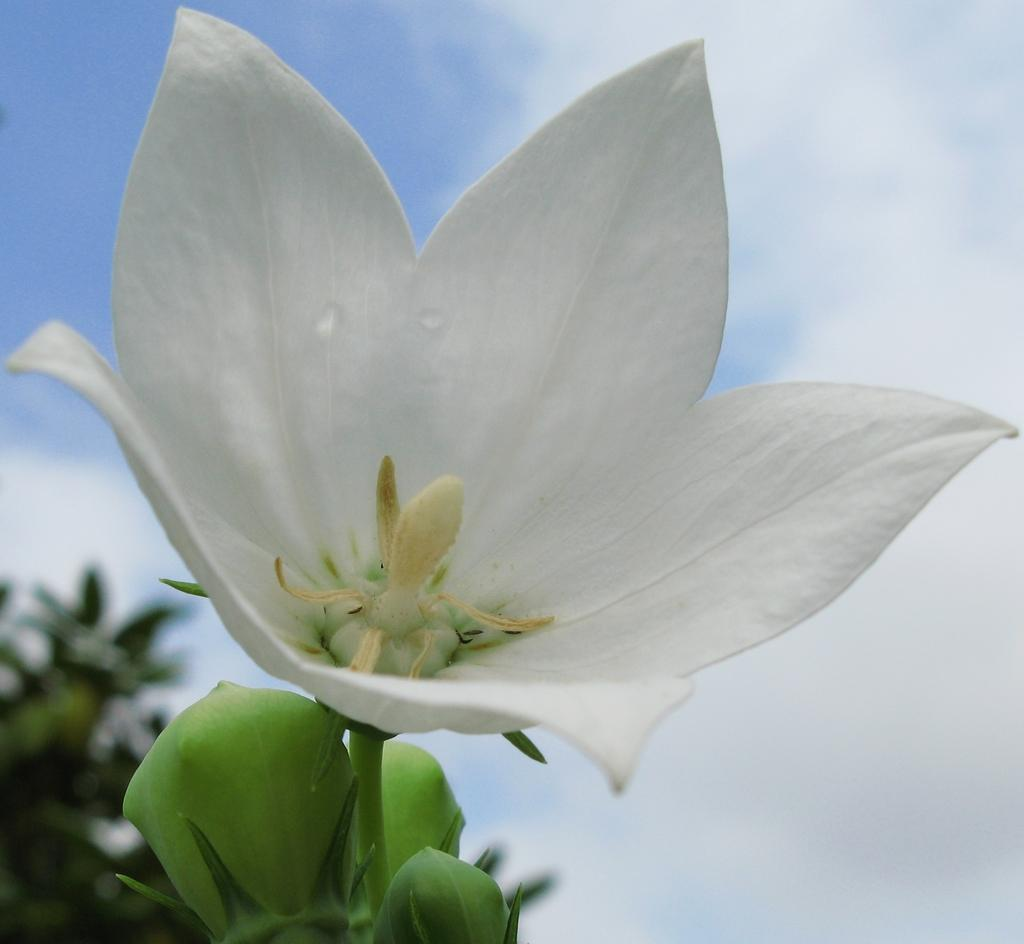What type of flower is in the image? There is a white color flower in the image. Can you describe the flower's structure? The flower has a stem and buds. What can be seen in the background of the image? There are trees and the sky visible in the background of the image. What is the condition of the sky in the image? Clouds are present in the sky. Can you tell me how many toes the tiger has in the image? There is no tiger present in the image; it features a white color flower with a stem and buds. What type of bed is visible in the image? There is no bed present in the image; it features a white color flower with a stem and buds, trees in the background, and a cloudy sky. 